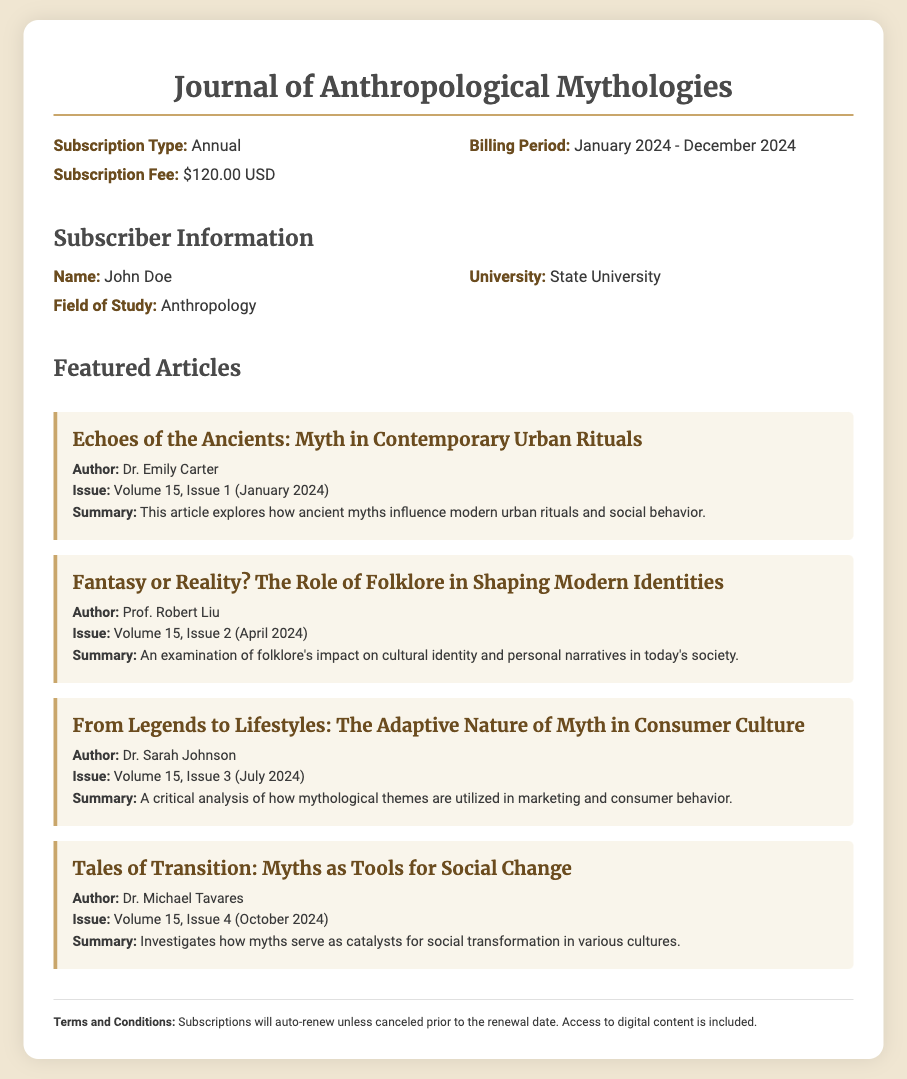What is the subscription type? The subscription type is specified in the document under subscription information.
Answer: Annual What is the billing period? The billing period is outlined in the subscription information section.
Answer: January 2024 - December 2024 What is the subscription fee? The subscription fee can be found in the subscription information section of the document.
Answer: $120.00 USD Who is the author of "Echoes of the Ancients: Myth in Contemporary Urban Rituals"? This information is available in the featured articles section of the document.
Answer: Dr. Emily Carter Which volume and issue includes "Fantasy or Reality? The Role of Folklore in Shaping Modern Identities"? This detail is mentioned in the featured articles section regarding publication specifics.
Answer: Volume 15, Issue 2 What is the main focus of Dr. Sarah Johnson's article? The summary of the article contains the main focus.
Answer: Consumer culture What is the title of the last featured article? The title can be found in the featured articles section of the document.
Answer: Tales of Transition: Myths as Tools for Social Change What happens to subscriptions upon renewal? The terms and conditions section provides information on subscription renewals.
Answer: Auto-renew What is included with the subscription? The subscription details mention the inclusions under terms and conditions.
Answer: Digital content 